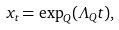Convert formula to latex. <formula><loc_0><loc_0><loc_500><loc_500>x _ { t } = \exp _ { Q } ( \Lambda _ { Q } t ) ,</formula> 